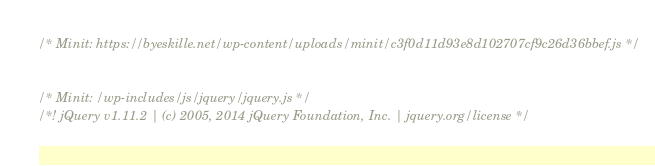Convert code to text. <code><loc_0><loc_0><loc_500><loc_500><_JavaScript_>

/* Minit: https://byeskille.net/wp-content/uploads/minit/c3f0d11d93e8d102707cf9c26d36bbef.js */


/* Minit: /wp-includes/js/jquery/jquery.js */
/*! jQuery v1.11.2 | (c) 2005, 2014 jQuery Foundation, Inc. | jquery.org/license */</code> 